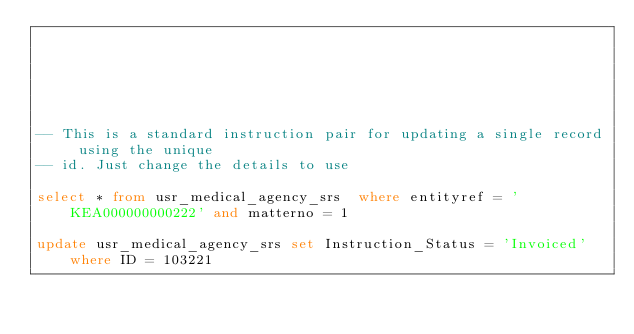<code> <loc_0><loc_0><loc_500><loc_500><_SQL_>





-- This is a standard instruction pair for updating a single record using the unique
-- id. Just change the details to use

select * from usr_medical_agency_srs  where entityref = 'KEA000000000222' and matterno = 1

update usr_medical_agency_srs set Instruction_Status = 'Invoiced' where ID = 103221</code> 